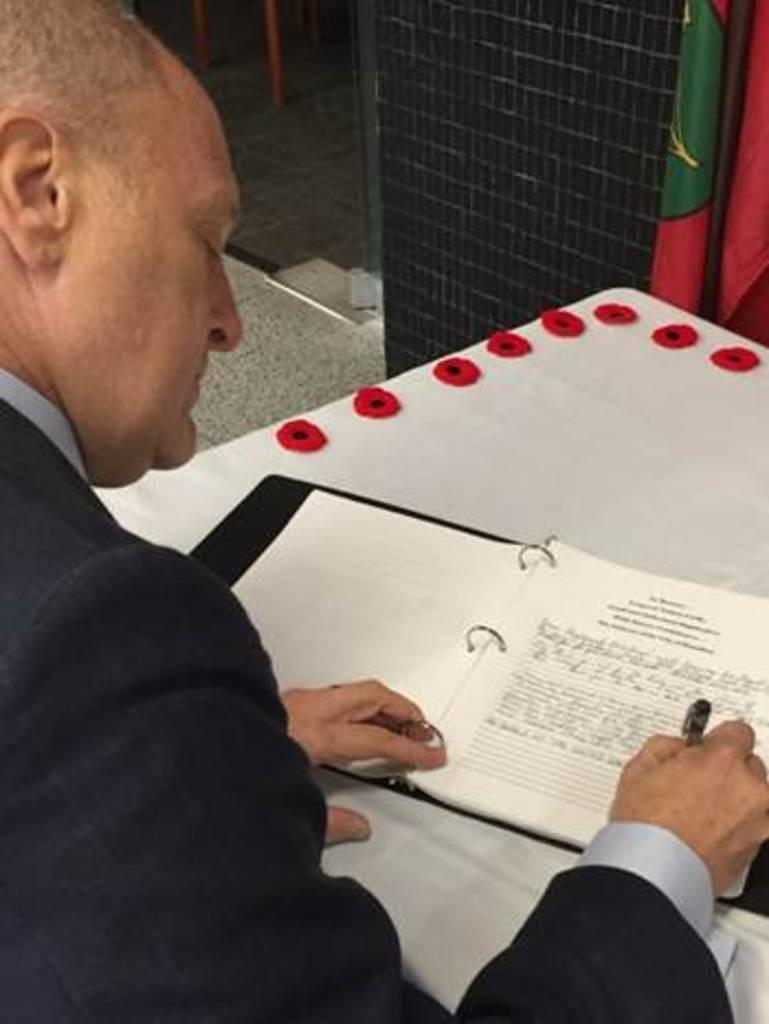Who is present in the image? There is a person in the image. What is the person wearing? The person is wearing clothes. What is the person doing in the image? The person is writing on a book. Where is the book located? The book is on a table. What type of joke is the person telling in the image? There is no joke being told in the image; the person is writing on a book. 